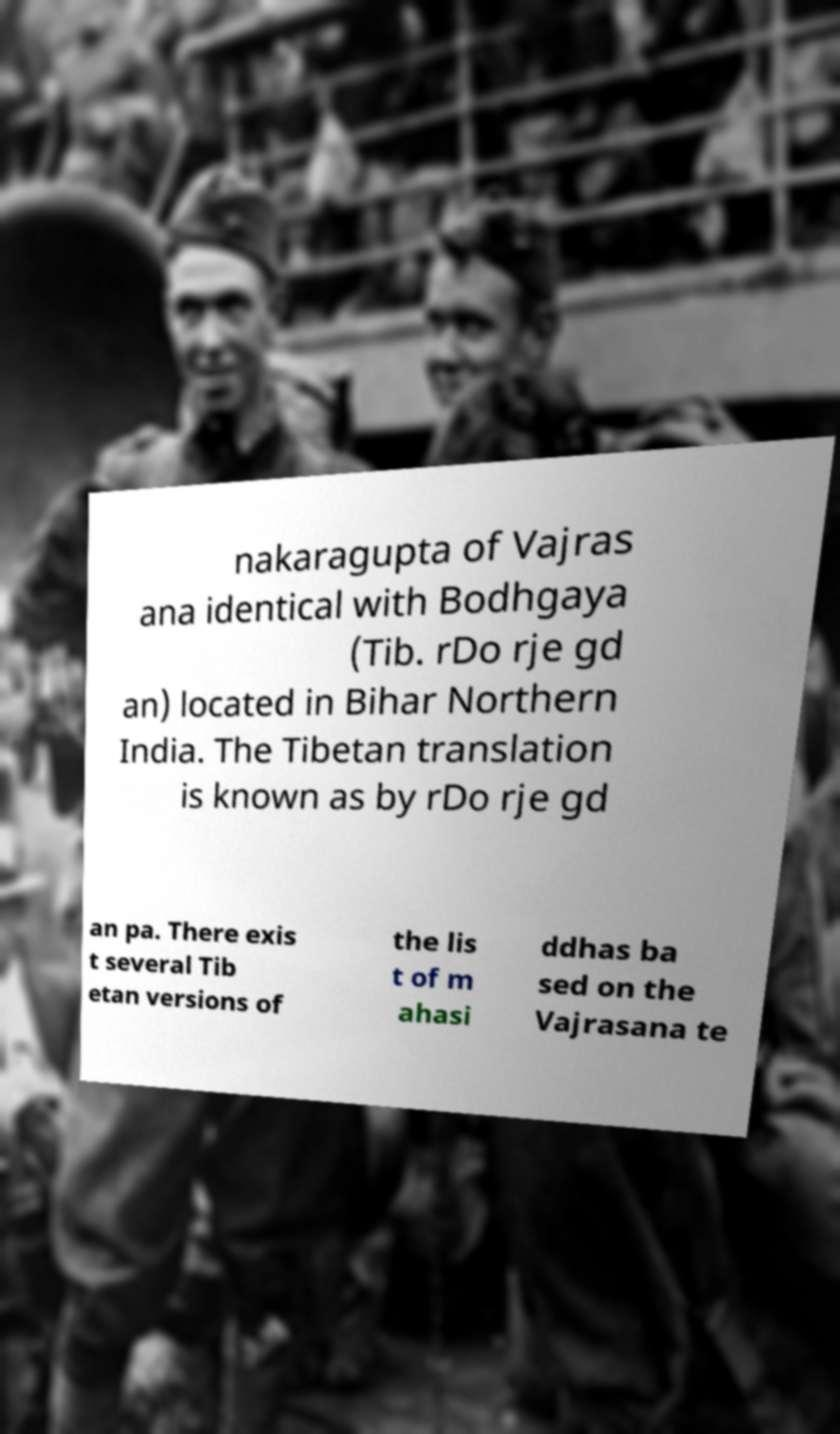For documentation purposes, I need the text within this image transcribed. Could you provide that? nakaragupta of Vajras ana identical with Bodhgaya (Tib. rDo rje gd an) located in Bihar Northern India. The Tibetan translation is known as by rDo rje gd an pa. There exis t several Tib etan versions of the lis t of m ahasi ddhas ba sed on the Vajrasana te 